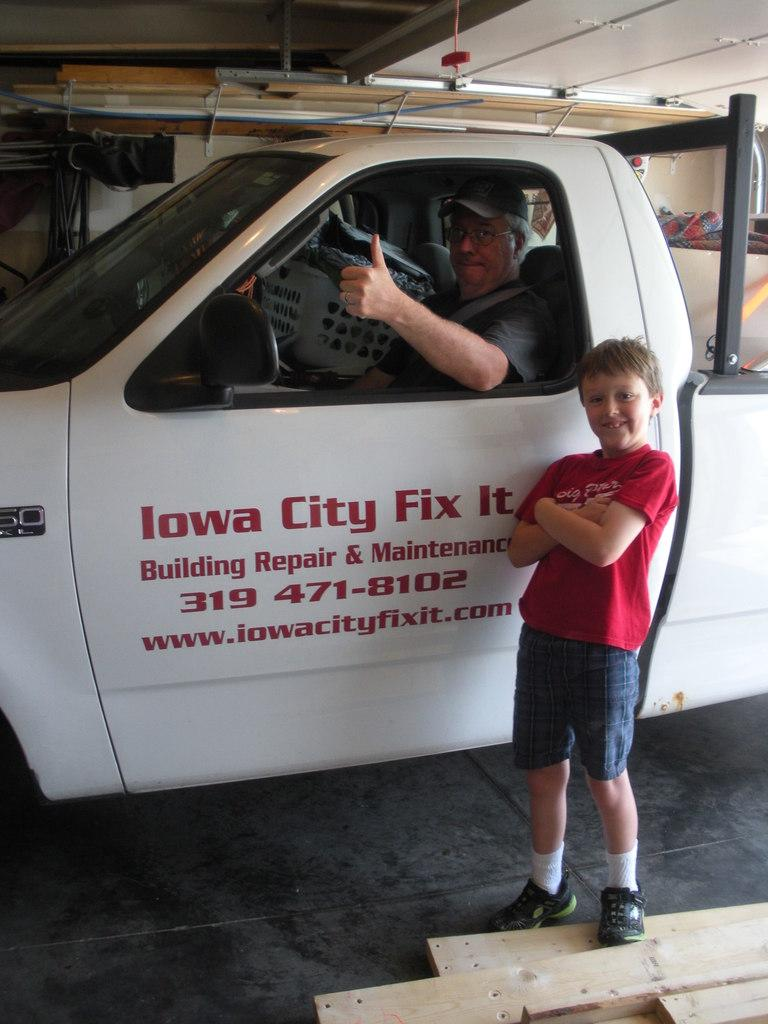What is the man doing in the image? The man is sitting in a vehicle. Can you describe the boy in the image? The boy is wearing a red t-shirt and standing near a car. What is the boy's proximity to the vehicle in the image? The boy is standing near a car. What type of bells can be heard ringing in the image? There are no bells present in the image, and therefore no sound can be heard. What topic are the man and the boy discussing in the image? The image does not depict a discussion between the man and the boy, so we cannot determine the topic of their conversation. 